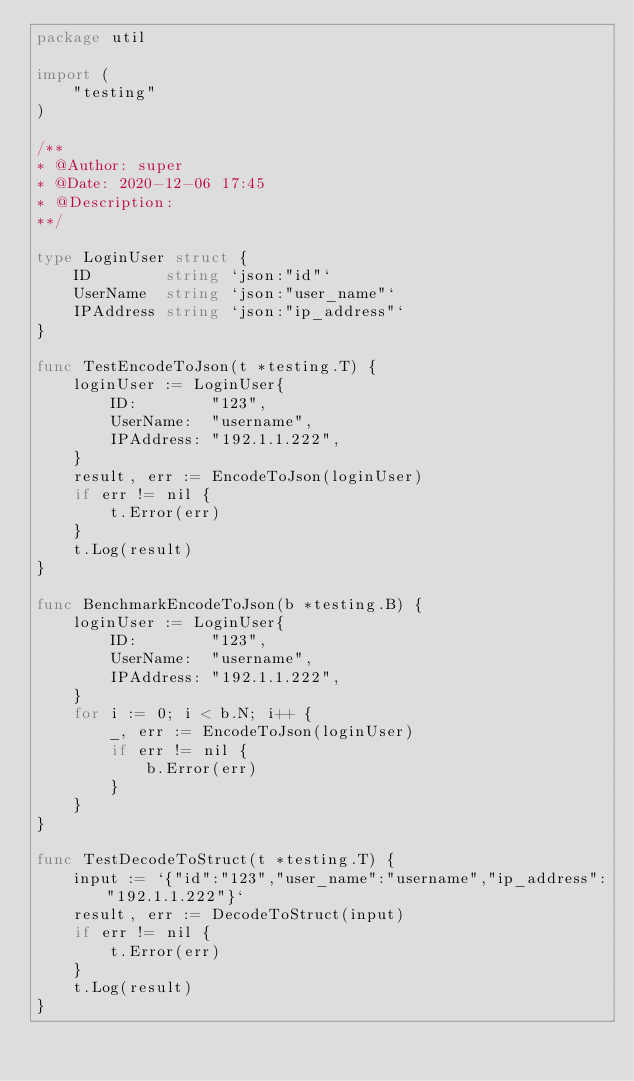<code> <loc_0><loc_0><loc_500><loc_500><_Go_>package util

import (
	"testing"
)

/**
* @Author: super
* @Date: 2020-12-06 17:45
* @Description:
**/

type LoginUser struct {
	ID        string `json:"id"`
	UserName  string `json:"user_name"`
	IPAddress string `json:"ip_address"`
}

func TestEncodeToJson(t *testing.T) {
	loginUser := LoginUser{
		ID:        "123",
		UserName:  "username",
		IPAddress: "192.1.1.222",
	}
	result, err := EncodeToJson(loginUser)
	if err != nil {
		t.Error(err)
	}
	t.Log(result)
}

func BenchmarkEncodeToJson(b *testing.B) {
	loginUser := LoginUser{
		ID:        "123",
		UserName:  "username",
		IPAddress: "192.1.1.222",
	}
	for i := 0; i < b.N; i++ {
		_, err := EncodeToJson(loginUser)
		if err != nil {
			b.Error(err)
		}
	}
}

func TestDecodeToStruct(t *testing.T) {
	input := `{"id":"123","user_name":"username","ip_address":"192.1.1.222"}`
	result, err := DecodeToStruct(input)
	if err != nil {
		t.Error(err)
	}
	t.Log(result)
}
</code> 